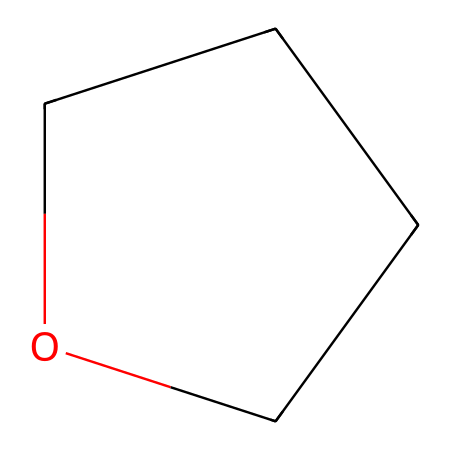What is the molecular formula of tetrahydrofuran? By examining the SMILES representation, we can count the number of carbon (C), hydrogen (H), and oxygen (O) atoms present. The structure shows 4 carbon atoms, 8 hydrogen atoms, and 1 oxygen atom. Therefore, we can deduce the molecular formula.
Answer: C4H8O How many carbon atoms are in tetrahydrofuran? From the SMILES representation, we can identify that there are 4 carbon (C) atoms linked in the cyclic structure.
Answer: 4 What type of functional group is present in tetrahydrofuran? Analyzing the structure, we see that tetrahydrofuran features an ether functional group, which is characterized by an oxygen atom bonded to two carbon atoms.
Answer: ether Is tetrahydrofuran a cyclic compound? The SMILES notation indicates a ring structure (C1...C1), which shows that the compound is indeed cyclic.
Answer: yes What is the total number of bonds in tetrahydrofuran? In the structure, we can identify the various bonds: there are 4 carbon-carbon bonds, 1 carbon-oxygen bond, and 8 carbon-hydrogen bonds. Adding these gives a total of 13 bonds.
Answer: 13 What is the primary use of tetrahydrofuran in industries? Tetrahydrofuran is widely used as a solvent in chemical processes, particularly in the pharmaceutical manufacturing sector due to its ability to dissolve a wide range of substances.
Answer: solvent 